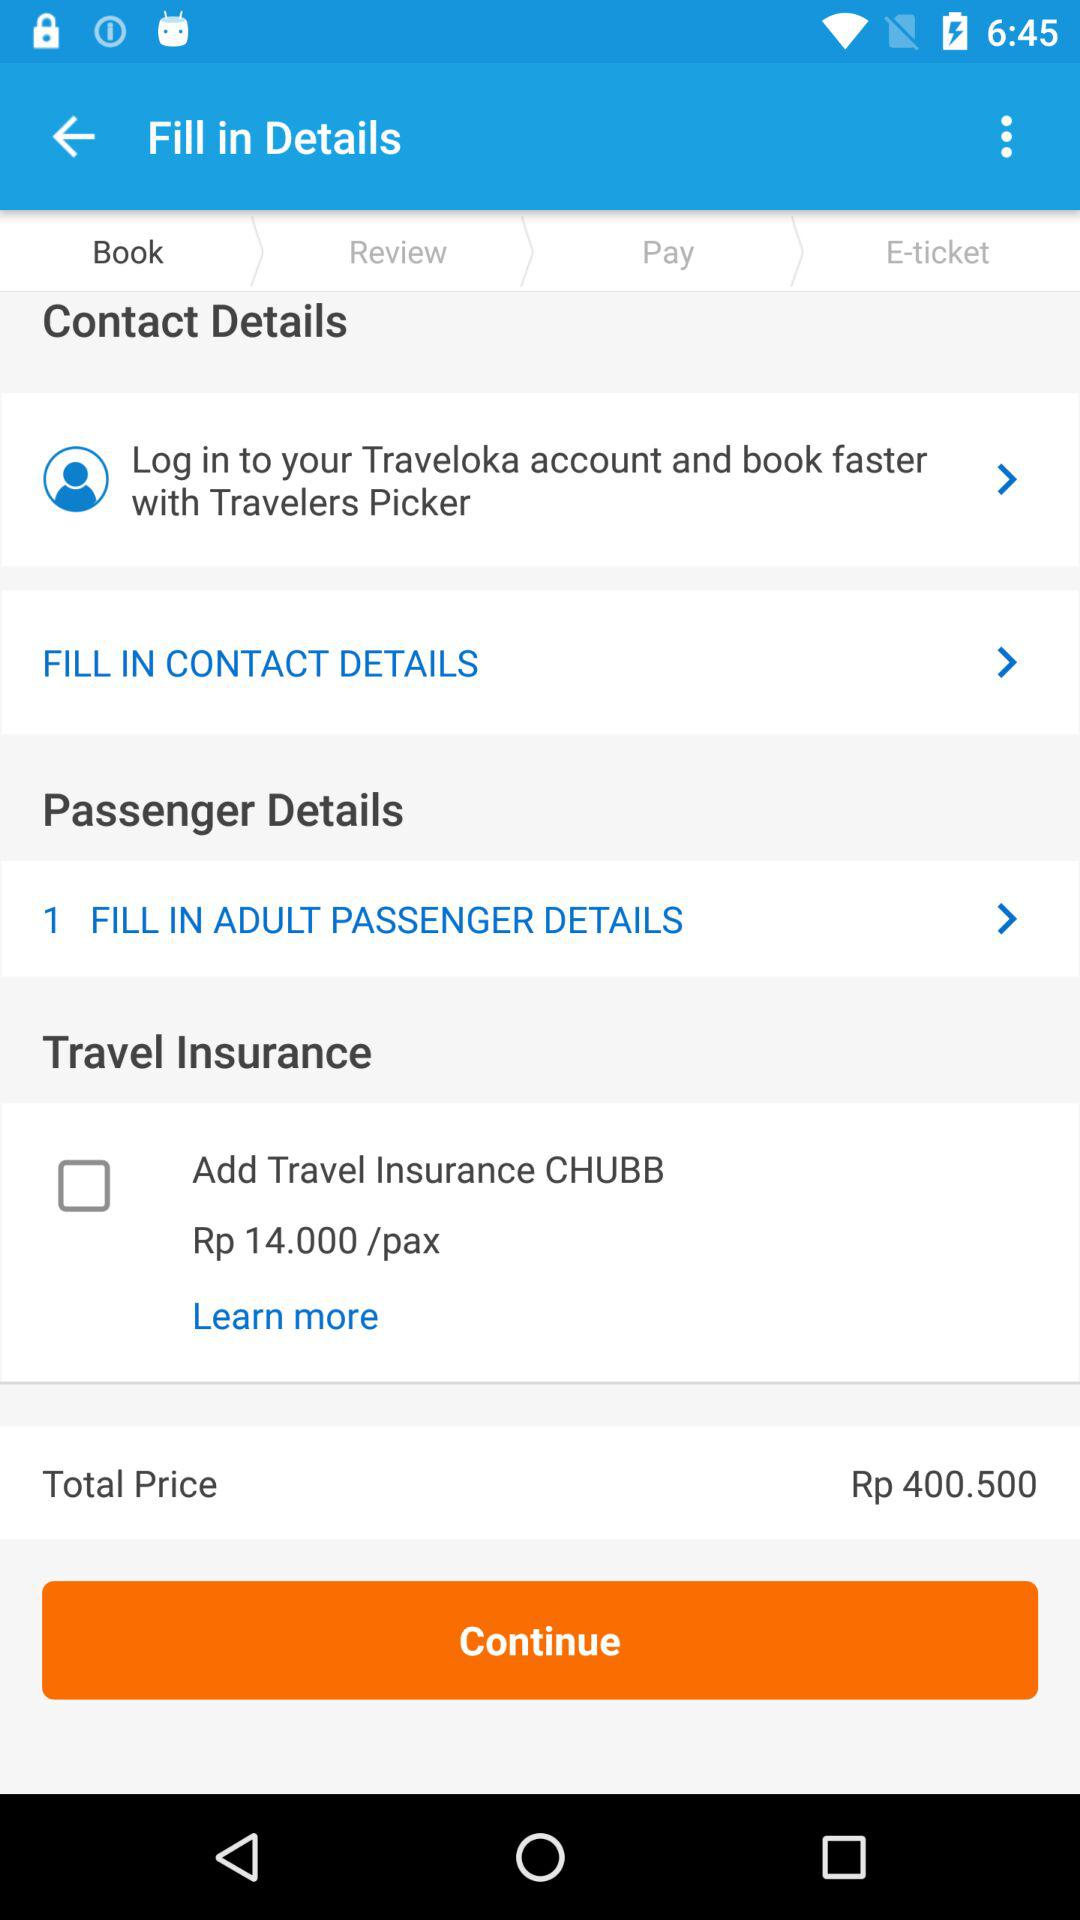What is the total price? The total price is Rp 400.500. 